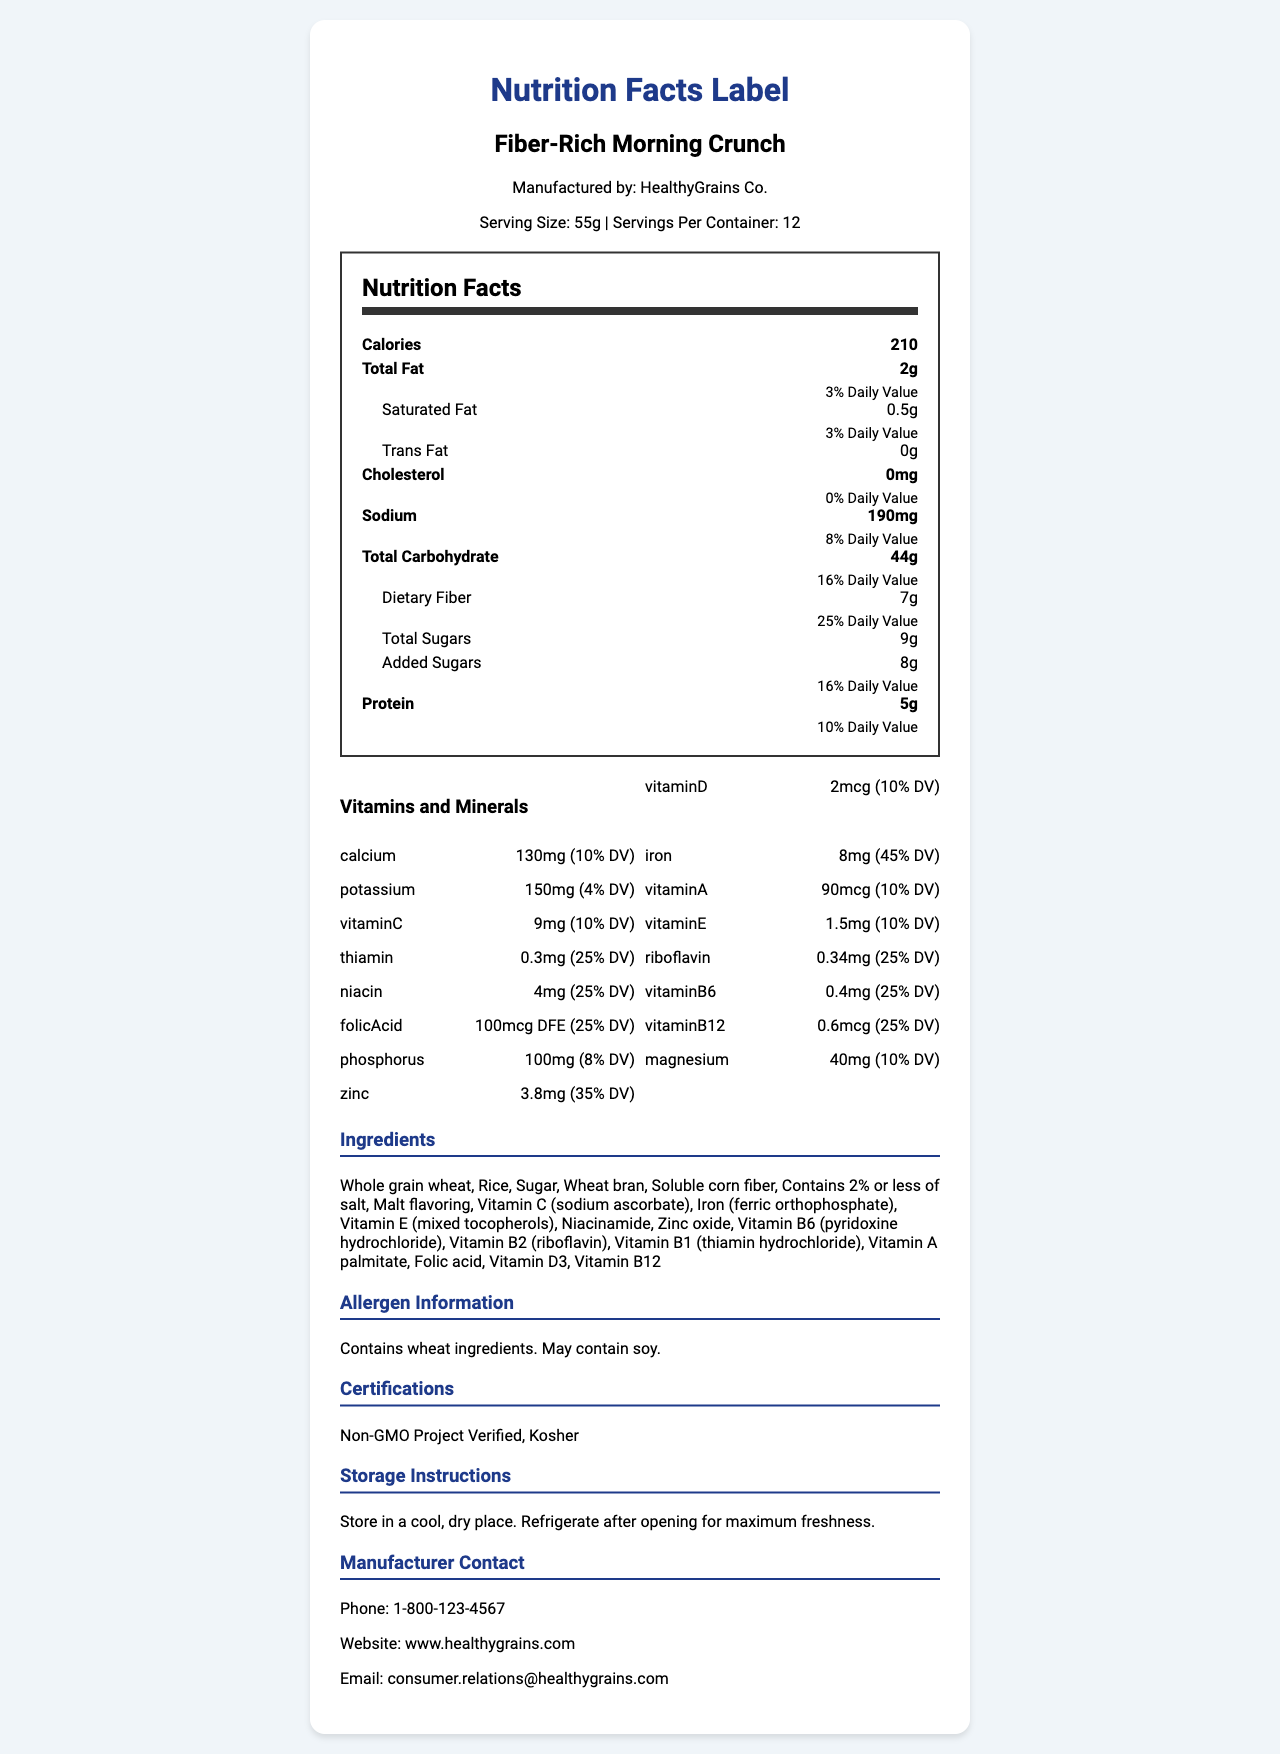what is the serving size? The serving size is mentioned in the product information section as 55g.
Answer: 55g how many calories are there per serving? The calories per serving are listed in the nutrition facts section as 210.
Answer: 210 how much total fat does the cereal contain, and what percentage of the daily value does it represent? The nutrition facts section lists 2g of total fat, which represents 3% of the daily value.
Answer: 2g, 3% which vitamin has the highest daily value percentage? The vitamins and minerals section shows Iron with the highest daily value percentage at 45%.
Answer: Iron what is the contact email for the manufacturer? The manufacturer contact section provides the email as consumer.relations@healthygrains.com.
Answer: consumer.relations@healthygrains.com how many grams of dietary fiber are in one serving of this cereal? The nutrition facts section lists 7g of dietary fiber.
Answer: 7g is this product certified kosher? The certifications section includes "Kosher" as one of the certifications.
Answer: Yes what type of grain is the first ingredient listed? The ingredients section lists "Whole grain wheat" as the first ingredient.
Answer: Whole grain wheat which of the following does the cereal not contain? A. Vitamin D B. Soy C. Malt flavoring The allergen information section states that the cereal "May contain soy," but the ingredients list does not confirm its presence.
Answer: B what are the storage instructions for the cereal? The storage instructions section provides this information.
Answer: Store in a cool, dry place. Refrigerate after opening for maximum freshness. when is the expiration date for this cereal? The expiration date section lists the date as 2024-06-30.
Answer: 2024-06-30 can the amount of protein in this cereal meet 100% of the daily value if you consume one serving? The nutrition facts section shows that one serving provides 10% of the daily value for protein.
Answer: No what is the format of the expiration date? The expiration date section specifies the format as YYYY-MM-DD.
Answer: YYYY-MM-DD which nutrient has the lowest amount per serving? A. Magnesium B. Vitamin D C. Folic Acid D. Zinc Vitamin D has 2 mcg per serving, whereas Magnesium has 40 mg, Folic Acid has 100 mcg DFE, and Zinc has 3.8 mg.
Answer: B what is the total number of certifications mentioned on the nutrition facts label? The certifications section lists "Non-GMO Project Verified" and "Kosher".
Answer: 2 does this product contain trans fat? The nutrition facts section shows that the amount of trans fat is 0g.
Answer: No describe the main idea of the document. The document provides comprehensive nutritional information and other relevant details about the cereal product manufactured by HealthyGrains Co.
Answer: This document is a detailed nutrition facts label for "Fiber-Rich Morning Crunch" cereal by HealthyGrains Co. It includes information on serving size, nutritional content, vitamins and minerals, ingredients, allergen information, certifications, and storage instructions. It provides contact details for the manufacturer and the expiration date. how many different types of vitamins and minerals are listed on the label? The vitamins and minerals section lists 16 different types, including Vitamin D, Calcium, Iron, etc.
Answer: 16 what company manufactures "Fiber-Rich Morning Crunch"? The product information section states that the manufacturer is HealthyGrains Co.
Answer: HealthyGrains Co. which ingredient in the cereal is classified as "less than 2%"? The ingredients section includes "Contains 2% or less of salt."
Answer: Salt what is the daily value percentage of niacin in one serving? The vitamins and minerals section lists the daily value percentage for niacin as 25%.
Answer: 25% what is the protein amount in grams per serving? The nutrition facts section shows the protein amount as 5g.
Answer: 5g Is there information about where the product should be stored? The storage instructions section provides specific details on where the product should be stored.
Answer: Yes does the document provide details about the country of manufacture? The document does not provide any information about the country where the product is manufactured.
Answer: Not enough information 